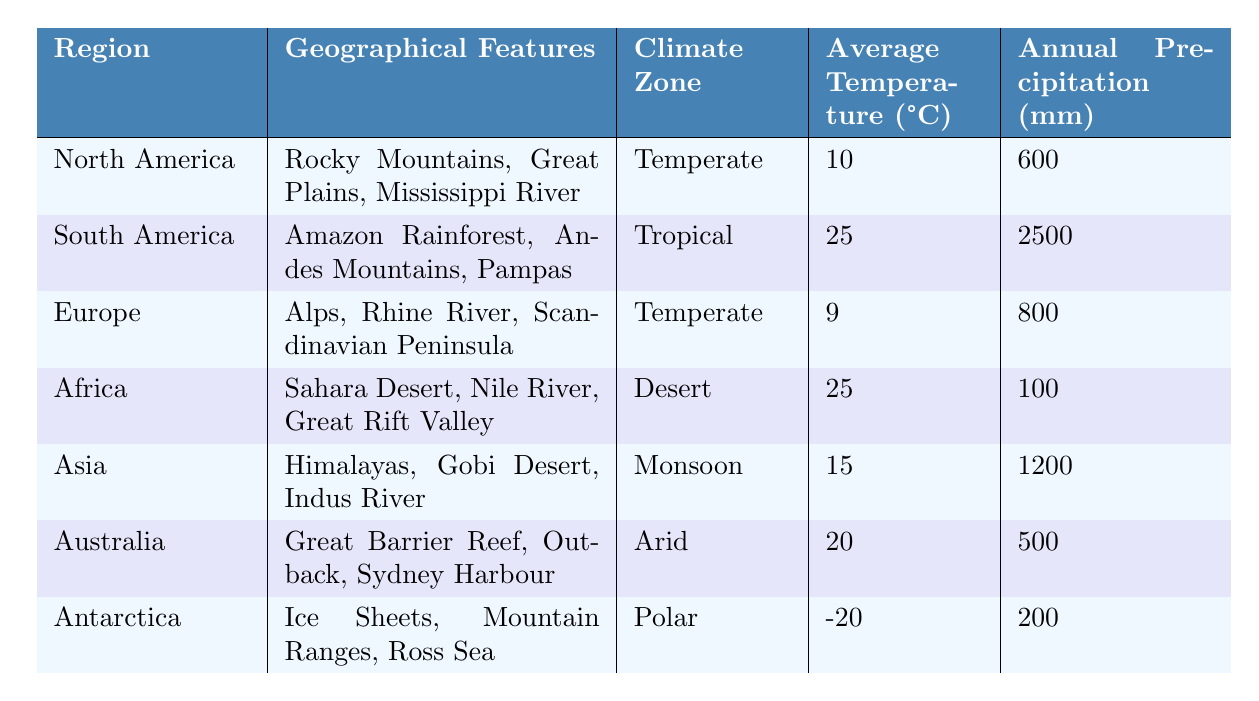What is the average temperature in Europe? The table states that the average temperature in Europe is listed as 9°C.
Answer: 9°C Which region has the highest annual precipitation? By comparing the annual precipitation values, South America has the highest at 2500 mm.
Answer: South America Is the climate zone of Africa classified as tropical? The table indicates that Africa's climate zone is classified as Desert, not Tropical.
Answer: No What is the difference in average temperature between North America and Australia? The average temperature in North America is 10°C, and in Australia, it is 20°C. The difference is 20°C - 10°C = 10°C.
Answer: 10°C Which region has the lowest average temperature? Antarctica has the lowest average temperature at -20°C according to the table.
Answer: Antarctica What is the average annual precipitation for regions classified as Temperate? The annual precipitation for North America is 600 mm and for Europe is 800 mm. The average is (600 + 800) / 2 = 700 mm.
Answer: 700 mm Does Asia have a higher average temperature than Africa? Asia's average temperature is 15°C, while Africa's average temperature is 25°C. Since 15°C is less than 25°C, Asia does not have a higher average temperature.
Answer: No Which region has a monsoon climate zone and what are its geographical features? Asia is classified under Monsoon climate, with geographical features including the Himalayas, Gobi Desert, and Indus River.
Answer: Asia, Himalayas, Gobi Desert, Indus River How does the annual precipitation of Australia compare to that of Africa? Australia has 500 mm of annual precipitation while Africa has 100 mm. Therefore, Australia has more precipitation by 500 mm - 100 mm = 400 mm.
Answer: Australia has 400 mm more What are the geographical features of South America and what is its climate zone? South America features the Amazon Rainforest, Andes Mountains, and Pampas, with a climate zone classified as Tropical.
Answer: Amazon Rainforest, Andes Mountains, Pampas; Tropical 